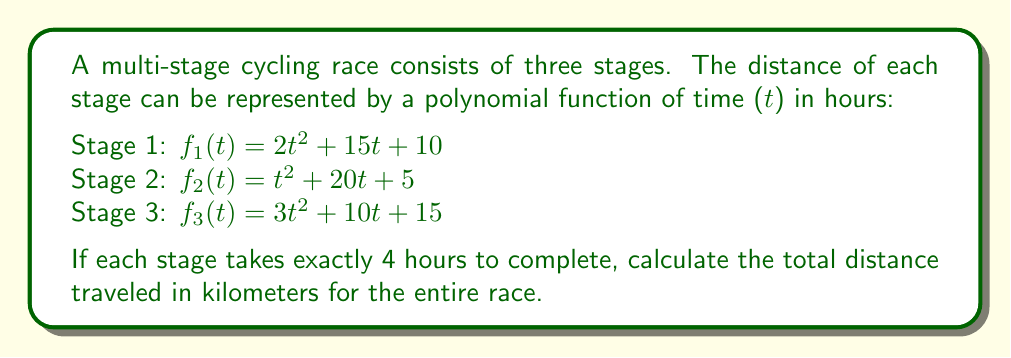Can you answer this question? To solve this problem, we need to follow these steps:

1) First, we need to calculate the distance for each stage by evaluating the polynomial functions at t = 4 hours.

   For Stage 1: 
   $$f_1(4) = 2(4)^2 + 15(4) + 10 = 2(16) + 60 + 10 = 32 + 60 + 10 = 102\text{ km}$$

   For Stage 2:
   $$f_2(4) = (4)^2 + 20(4) + 5 = 16 + 80 + 5 = 101\text{ km}$$

   For Stage 3:
   $$f_3(4) = 3(4)^2 + 10(4) + 15 = 3(16) + 40 + 15 = 48 + 40 + 15 = 103\text{ km}$$

2) Now that we have the distance for each stage, we can add them together to get the total distance:

   $$\text{Total Distance} = 102 + 101 + 103 = 306\text{ km}$$

This approach demonstrates the importance of integrity in cycling by accurately calculating and reporting the race distance, ensuring fair competition for all participants.
Answer: The total distance traveled in the multi-stage race is 306 km. 